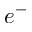<formula> <loc_0><loc_0><loc_500><loc_500>e ^ { - }</formula> 